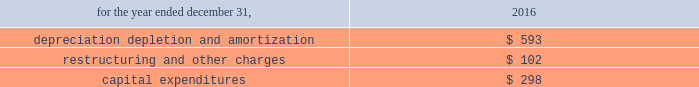On november 1 , 2016 , management evaluated the net assets of alcoa corporation for potential impairment and determined that no impairment charge was required .
The cash flows related to alcoa corporation have not been segregated and are included in the statement of consolidated cash flows for 2016 .
The table presents depreciation , depletion and amortization , restructuring and other charges , and purchases of property , plant and equipment of the discontinued operations related to alcoa corporation: .
Subsequent events management evaluated all activity of arconic and concluded that no subsequent events have occurred that would require recognition in the consolidated financial statements or disclosure in the notes to the consolidated financial statements , except as noted below : on january 22 , 2019 , the company announced that its board of directors ( the board ) had determined to no longer pursue a potential sale of arconic as part of its strategy and portfolio review .
On february 6 , 2019 , the company announced that the board appointed john c .
Plant , current chairman of the board , as chairman and chief executive officer of the company , effective february 6 , 2019 , to succeed chip blankenship , who ceased to serve as chief executive officer of the company and resigned as a member of the board , in each case as of that date .
In addition , the company announced that the board appointed elmer l .
Doty , current member of the board , as president and chief operating officer , a newly created position , effective february 6 , 2019 .
Mr .
Doty will remain a member of the board .
The company also announced that arthur d .
Collins , jr. , current member of the board , has been appointed interim lead independent director of the company , effective february 6 , 2019 .
On february 8 , 2019 , the company announced the following key initiatives as part of its ongoing strategy and portfolio review : plans to reduce operating costs , designed to maximize the impact in 2019 ; the planned separation of its portfolio into engineered products and forgings ( ep&f ) and global rolled products ( grp ) , with a spin-off of one of the businesses ; the potential sale of businesses that do not best fit into ep&f or grp ; execute its previously authorized $ 500 share repurchase program in the first half of 2019 ; the board authorized an additional $ 500 of share repurchases , effective through the end of 2020 ; and plans to reduce its quarterly common stock dividend from $ 0.06 to $ 0.02 per share .
On february 19 , 2019 , the company entered into an accelerated share repurchase ( 201casr 201d ) agreement with jpmorgan chase bank to repurchase $ 700 of its common stock , pursuant to the share repurchase program previously authorized by the board .
Under the asr agreement , arconic will receive initial delivery of approximately 32 million shares on february 21 , 2019 .
The final number of shares to be repurchased will be based on the volume-weighted average price of arconic 2019s common stock during the term of the transaction , less a discount .
The asr agreement is expected to be completed during the first half of the company will evaluate its organizational structure in conjunction with the planned separation of its portfolio and changes to its reportable segments are expected in the first half of 2019. .
Considering the asr agreement , what will be the total value associated with the repurchase program of common stock , in millions of dollars? 
Rationale: it is the price per repurchased share multiplied by the total amount of shares delivered .
Computations: (700 * 32)
Answer: 22400.0. 